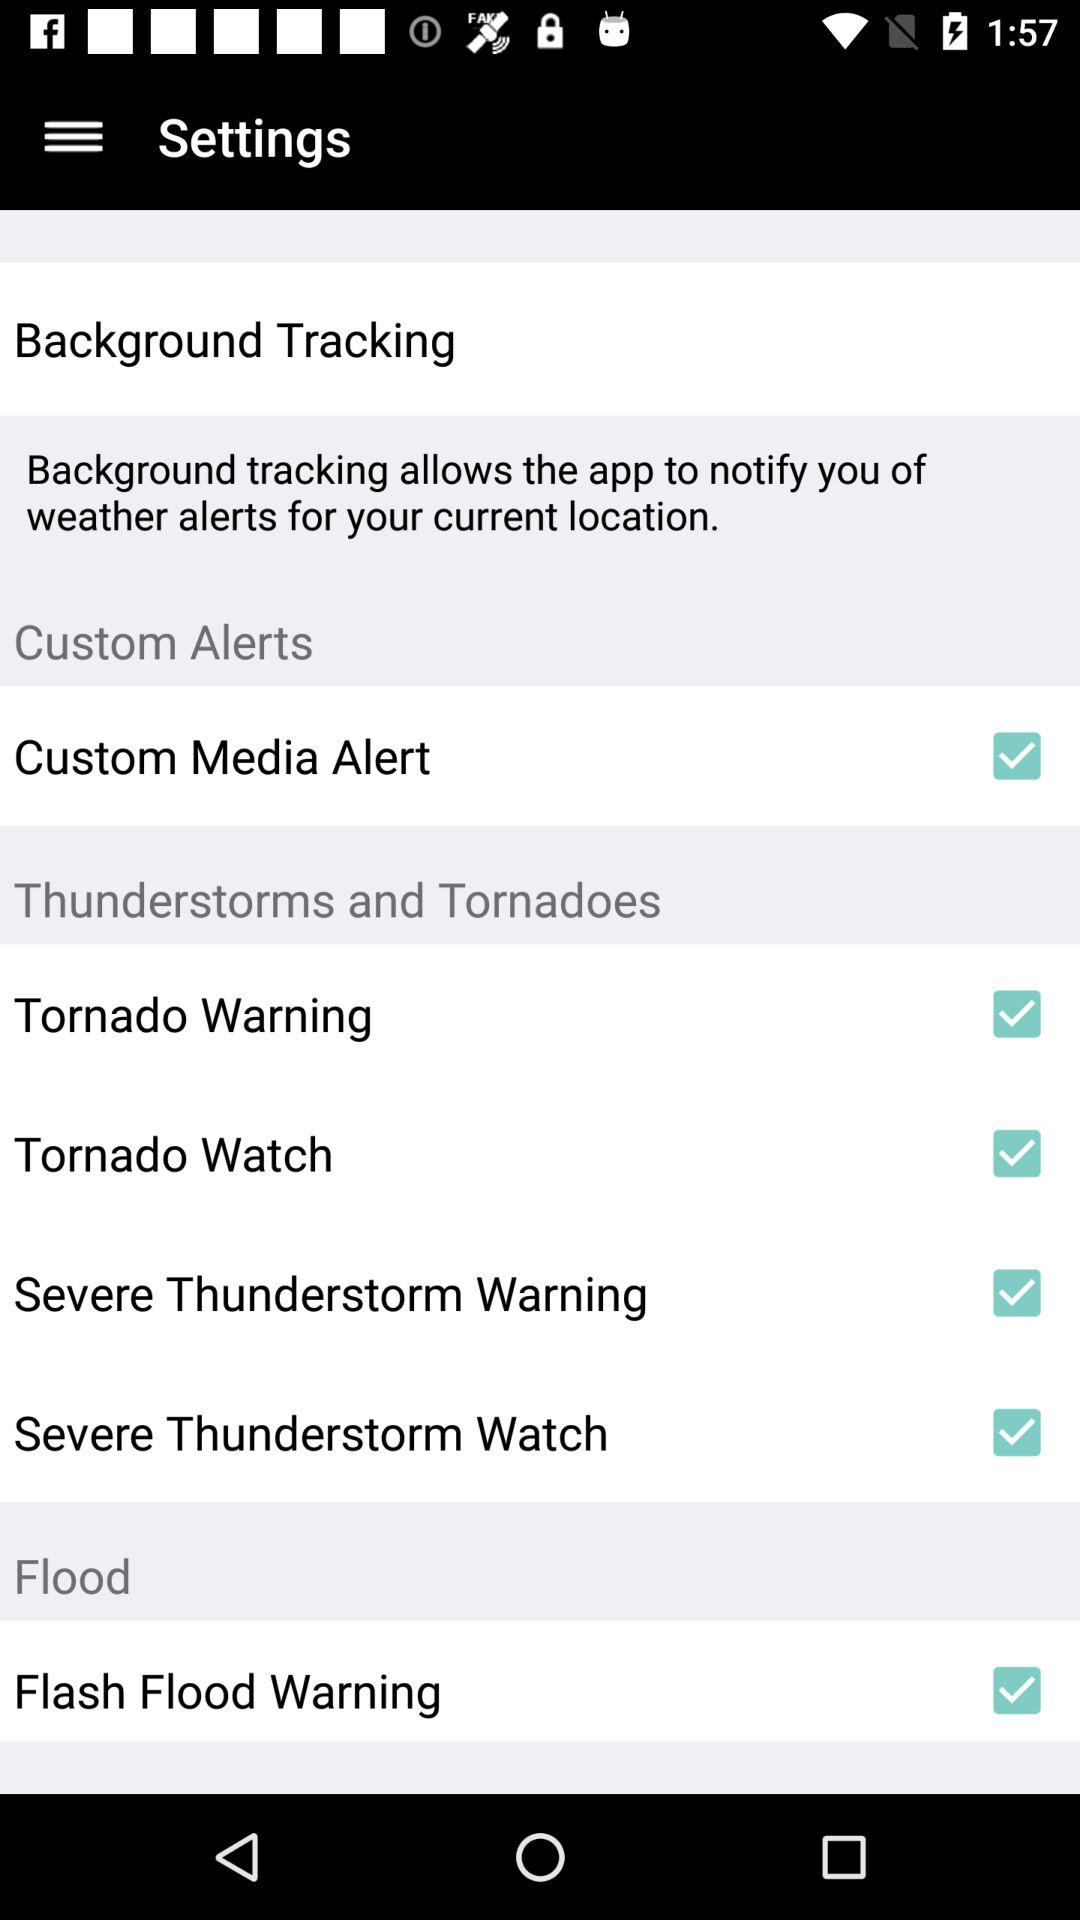Is "Custom Media Alert" checked or not? "Custom Media Alert" is "checked". 